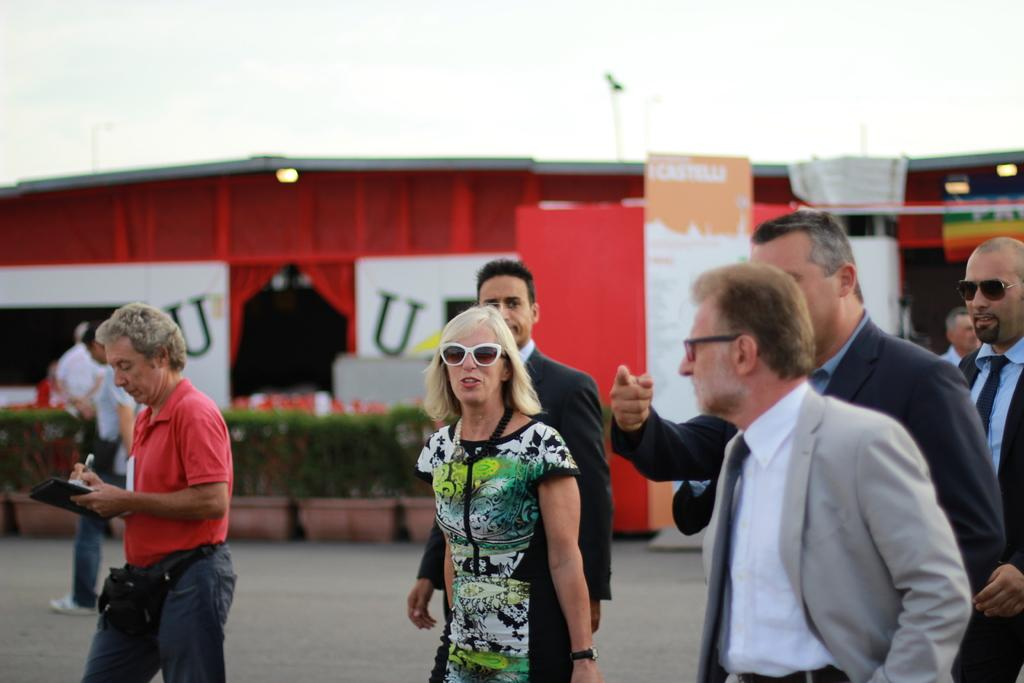How many people are in the image? There is a group of people in the image, but the exact number cannot be determined from the provided facts. What is the color of the compartment behind the group of people? The compartment behind the group of people is red. What is located in front of the red compartment? There are plants in front of the red compartment. Can you see any fangs in the image? There is no mention of fangs in the provided facts, so it cannot be determined if any are present. 